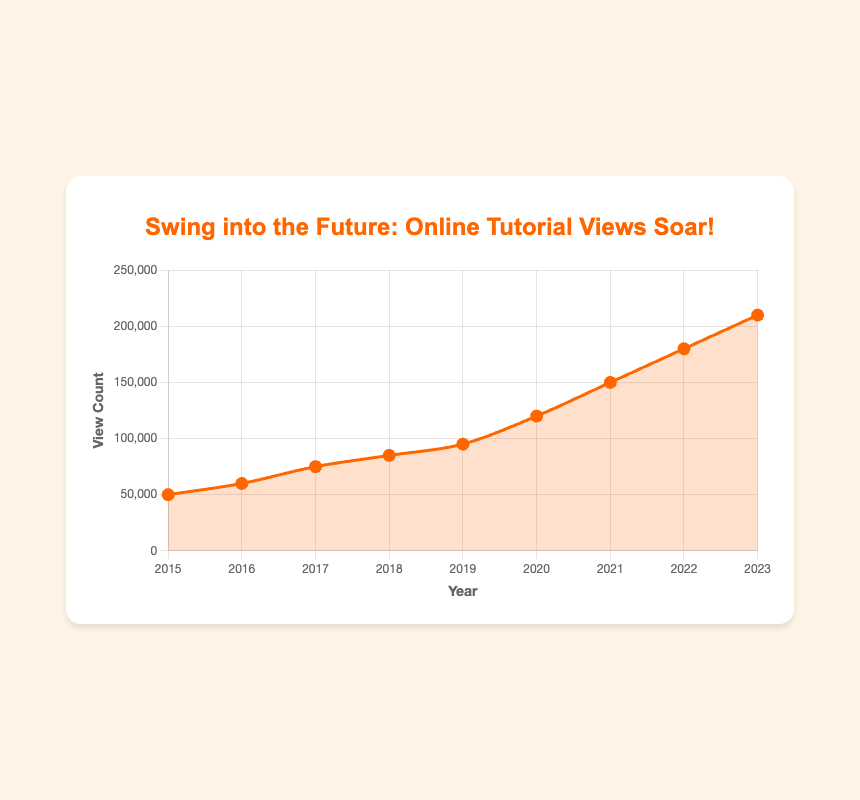What year had the steepest increase in online swing dance tutorial views? To find the steepest increase, subtract the ViewCount of each year from the previous year's. The largest difference is between 2019 and 2020 (120,000 - 95,000 = 25,000).
Answer: 2020 How many views in total were there from 2015 to 2018? Add the views from each year from 2015 to 2018: 50,000 (2015) + 60,000 (2016) + 75,000 (2017) + 85,000 (2018) = 270,000.
Answer: 270,000 What was the view count difference between 2017 and 2023? Subtract the view count of 2017 from 2023: 210,000 (2023) - 75,000 (2017) = 135,000.
Answer: 135,000 How many years experienced a growth of 10,000 or more views compared to the previous year? Calculate the growth each year and count the years with increases of 10,000 or more: 2016 over 2015 (10,000), 2017 over 2016 (15,000), 2018 over 2017 (10,000), 2019 over 2018 (10,000), 2020 over 2019 (25,000), 2021 over 2020 (30,000), 2022 over 2021 (30,000), 2023 over 2022 (30,000). Eight years had such growth.
Answer: 8 What is the average yearly view count from 2015 to 2023? Sum the total views from 2015 to 2023 and divide by the number of years: (50,000 + 60,000 + 75,000 + 85,000 + 95,000 + 120,000 + 150,000 + 180,000 + 210,000) / 9 ≈ 113,889.
Answer: 113,889 Which year had the lowest number of views, and what was the count? Identify the smallest number in the list. The lowest number of views was in 2015 with 50,000 views.
Answer: 2015, 50,000 Compare the view count of 2022 with that of 2021. Which year had more views and by how much? Subtract the view count of 2021 from 2022: 180,000 (2022) - 150,000 (2021) = 30,000.
Answer: 2022 had 30,000 more views What is the total increase in views from 2015 to 2023? Subtract the view count of 2015 from 2023: 210,000 (2023) - 50,000 (2015) = 160,000.
Answer: 160,000 In which two consecutive years did the view count jump by over 30,000? Calculate the difference between each pair of consecutive years: 2023 - 2022 = 30,000. No two consecutive years jumped by more than 30,000.
Answer: None 